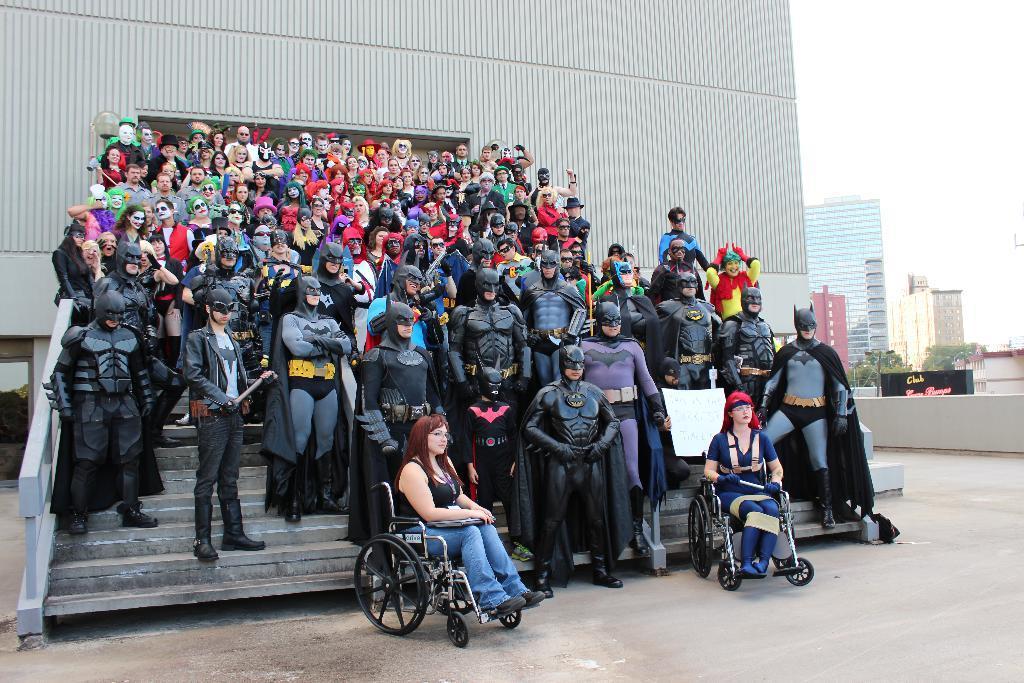Can you describe this image briefly? In this image, we can see a group of people wearing costumes. We can see the ground. We can see some stairs. We can see the railing. There are a few buildings. We can see some trees and a pole. We can see the sky and the wall. 